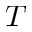Convert formula to latex. <formula><loc_0><loc_0><loc_500><loc_500>T</formula> 